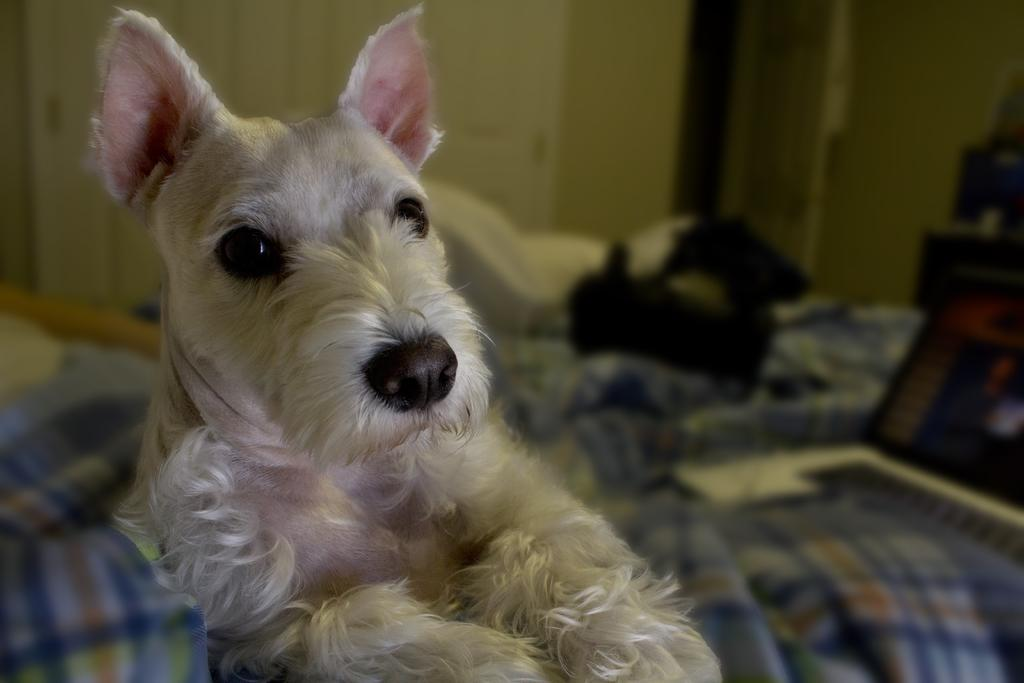What animal is on the bed in the image? There is a dog on the bed in the image. What else can be seen on the bed in the image? There are things on the bed in the image. What can be seen in the background of the image? There is a door visible in the background of the image, and a cupboard beside the door. What type of substance is being traded in the image? There is no indication of any substance being traded in the image. Can you see a fan in the image? There is no fan present in the image. 